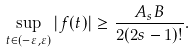Convert formula to latex. <formula><loc_0><loc_0><loc_500><loc_500>\sup _ { t \in ( - \varepsilon , \varepsilon ) } | f ( t ) | \geq \frac { A _ { s } B } { 2 ( 2 s - 1 ) ! } .</formula> 